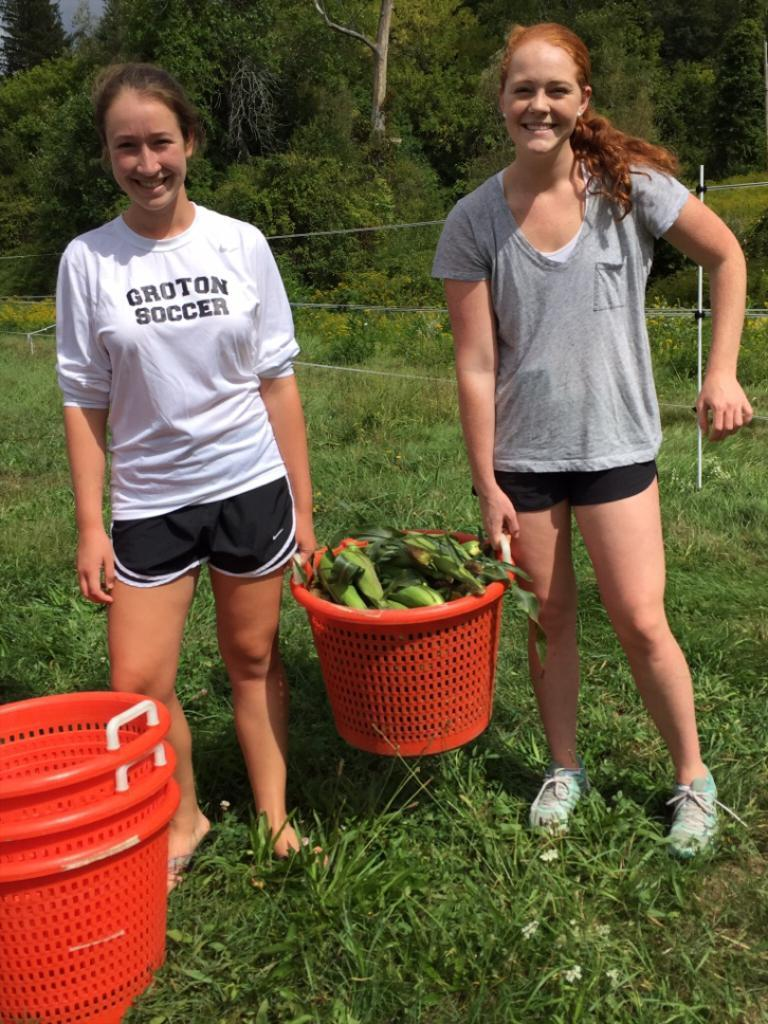<image>
Describe the image concisely. Girl wearing a white shirt which says Groton Soccer holdign a basket. 